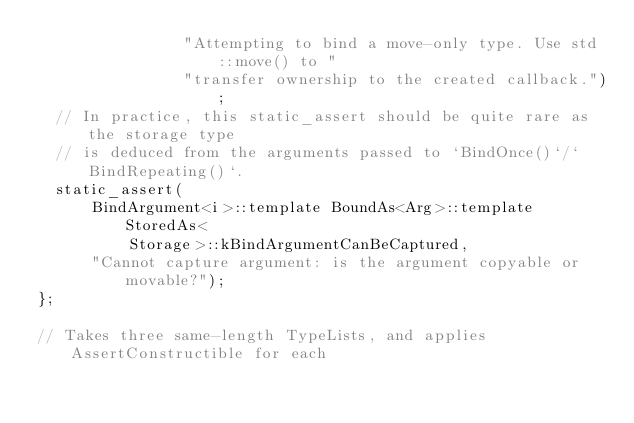Convert code to text. <code><loc_0><loc_0><loc_500><loc_500><_C_>                "Attempting to bind a move-only type. Use std::move() to "
                "transfer ownership to the created callback.");
  // In practice, this static_assert should be quite rare as the storage type
  // is deduced from the arguments passed to `BindOnce()`/`BindRepeating()`.
  static_assert(
      BindArgument<i>::template BoundAs<Arg>::template StoredAs<
          Storage>::kBindArgumentCanBeCaptured,
      "Cannot capture argument: is the argument copyable or movable?");
};

// Takes three same-length TypeLists, and applies AssertConstructible for each</code> 